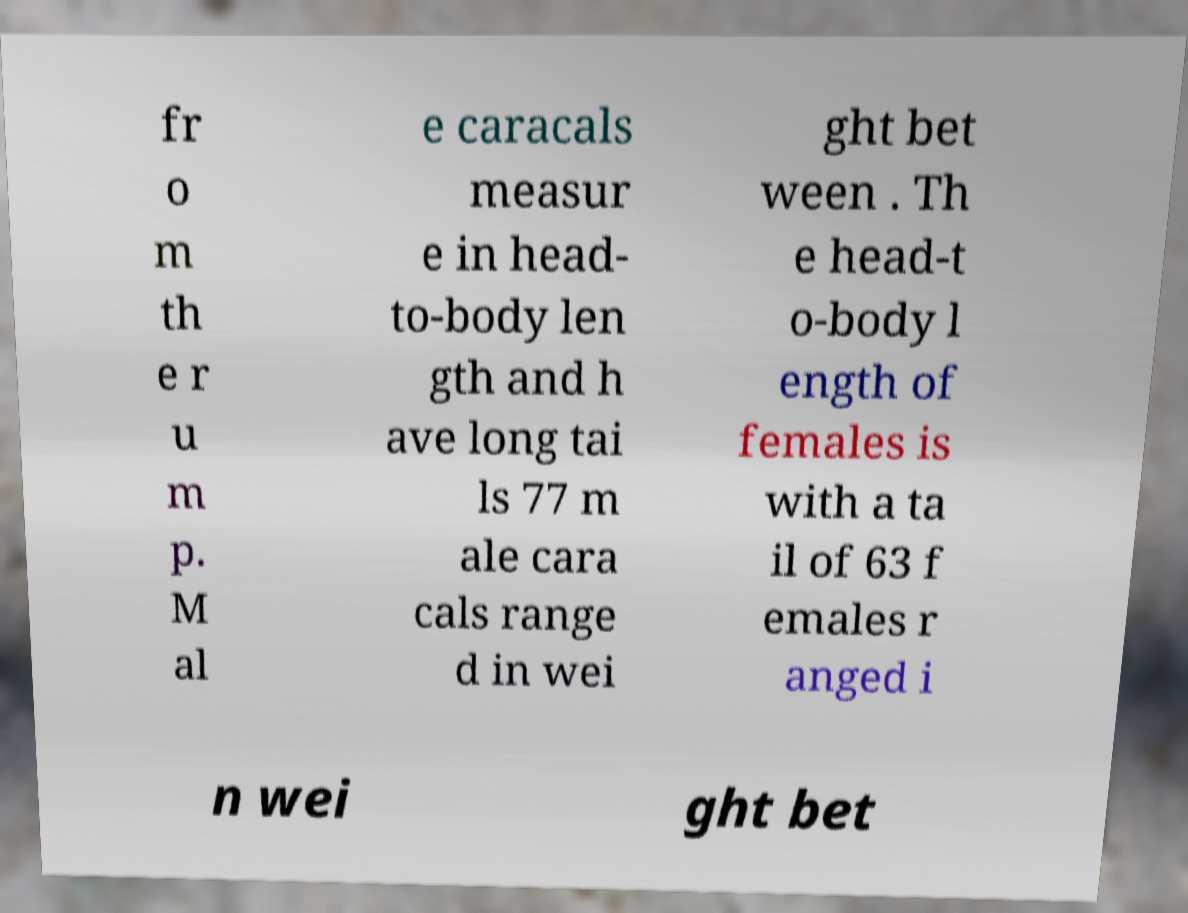Could you assist in decoding the text presented in this image and type it out clearly? fr o m th e r u m p. M al e caracals measur e in head- to-body len gth and h ave long tai ls 77 m ale cara cals range d in wei ght bet ween . Th e head-t o-body l ength of females is with a ta il of 63 f emales r anged i n wei ght bet 